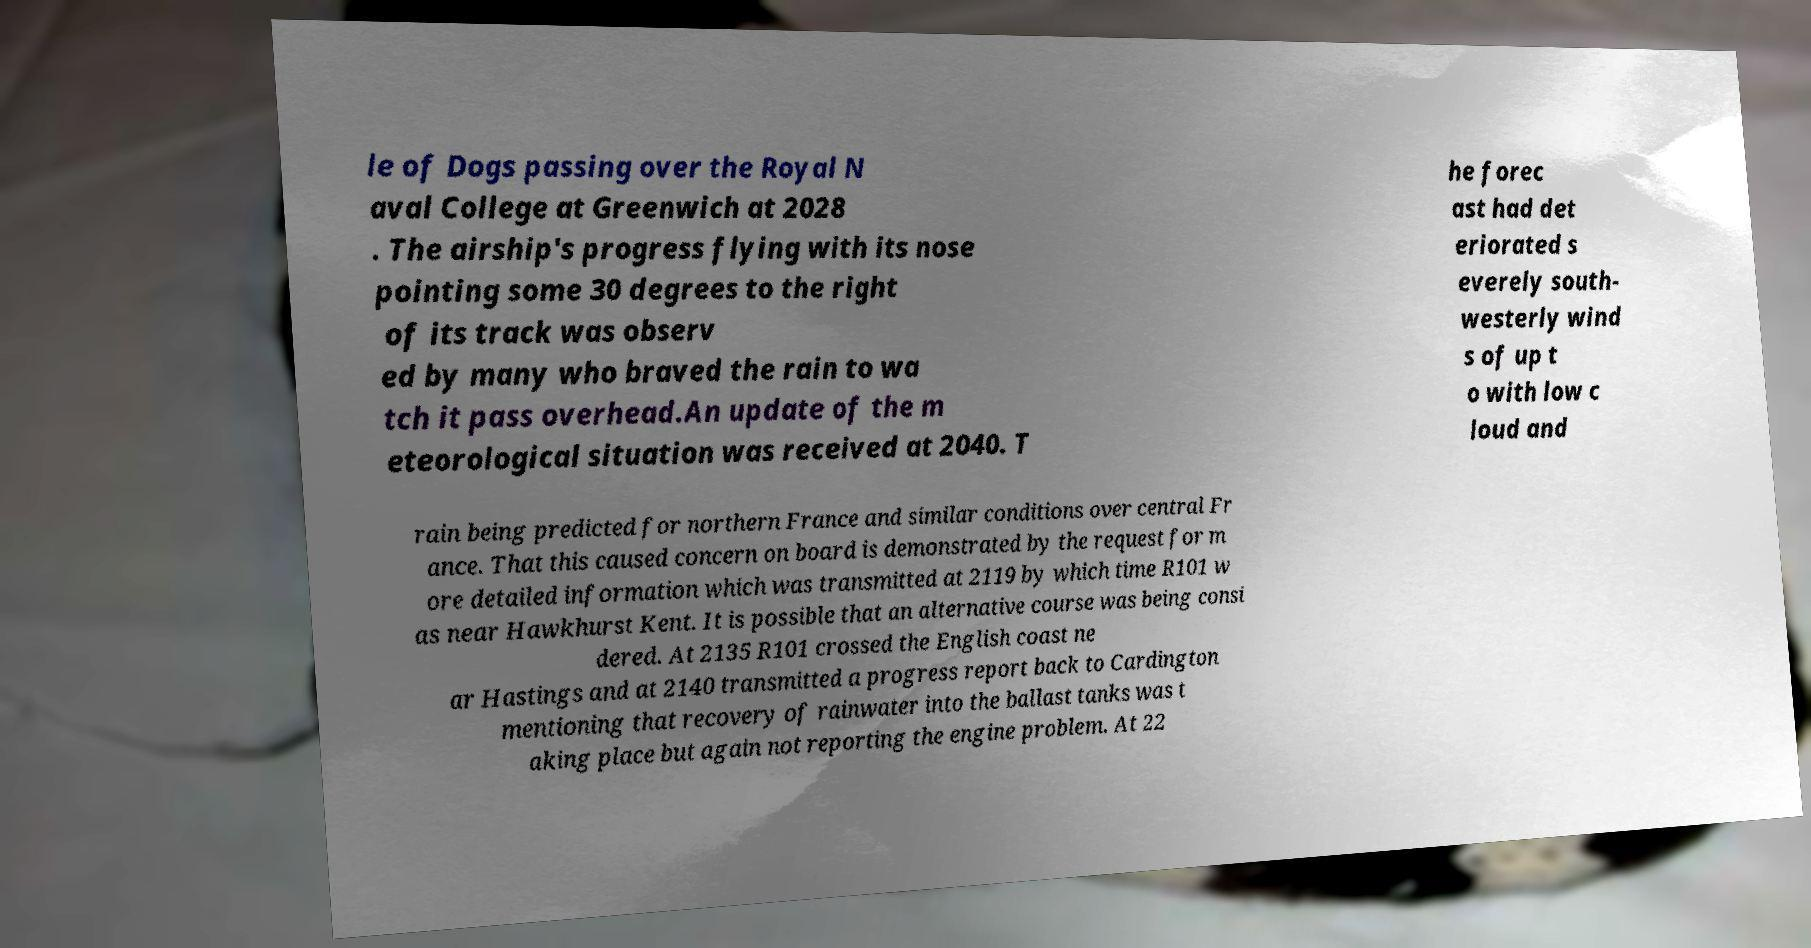Can you read and provide the text displayed in the image?This photo seems to have some interesting text. Can you extract and type it out for me? le of Dogs passing over the Royal N aval College at Greenwich at 2028 . The airship's progress flying with its nose pointing some 30 degrees to the right of its track was observ ed by many who braved the rain to wa tch it pass overhead.An update of the m eteorological situation was received at 2040. T he forec ast had det eriorated s everely south- westerly wind s of up t o with low c loud and rain being predicted for northern France and similar conditions over central Fr ance. That this caused concern on board is demonstrated by the request for m ore detailed information which was transmitted at 2119 by which time R101 w as near Hawkhurst Kent. It is possible that an alternative course was being consi dered. At 2135 R101 crossed the English coast ne ar Hastings and at 2140 transmitted a progress report back to Cardington mentioning that recovery of rainwater into the ballast tanks was t aking place but again not reporting the engine problem. At 22 